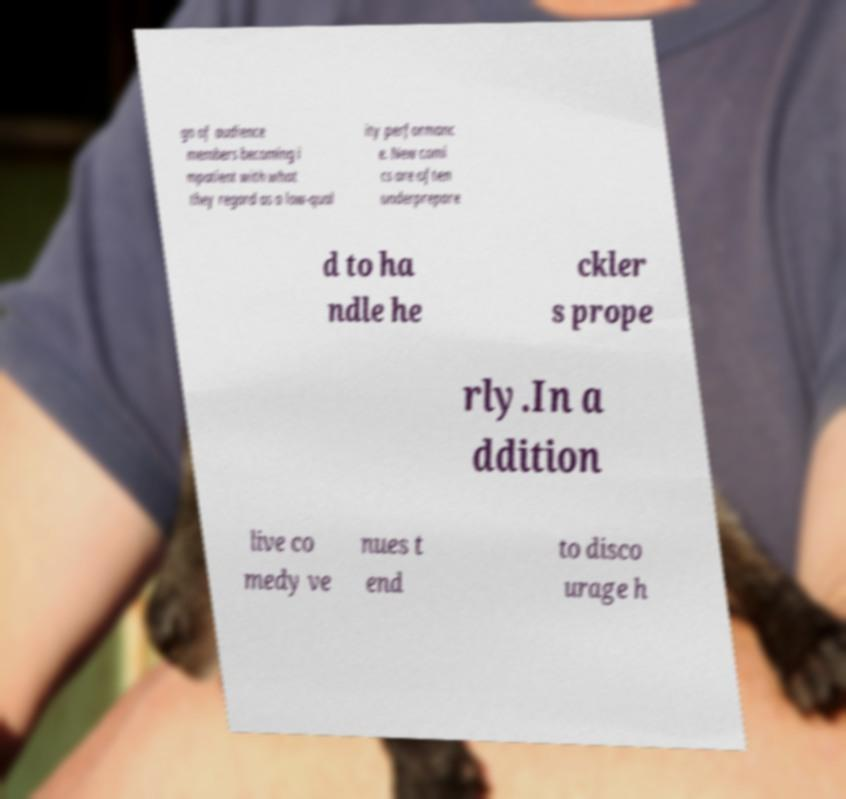Could you extract and type out the text from this image? gn of audience members becoming i mpatient with what they regard as a low-qual ity performanc e. New comi cs are often underprepare d to ha ndle he ckler s prope rly.In a ddition live co medy ve nues t end to disco urage h 